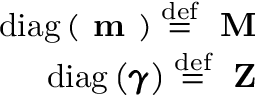<formula> <loc_0><loc_0><loc_500><loc_500>\begin{array} { r } { d i a g \left ( m \right ) \stackrel { d e f } { = } M } \\ { d i a g \left ( \pm b { \gamma } \right ) \stackrel { d e f } { = } Z } \end{array}</formula> 